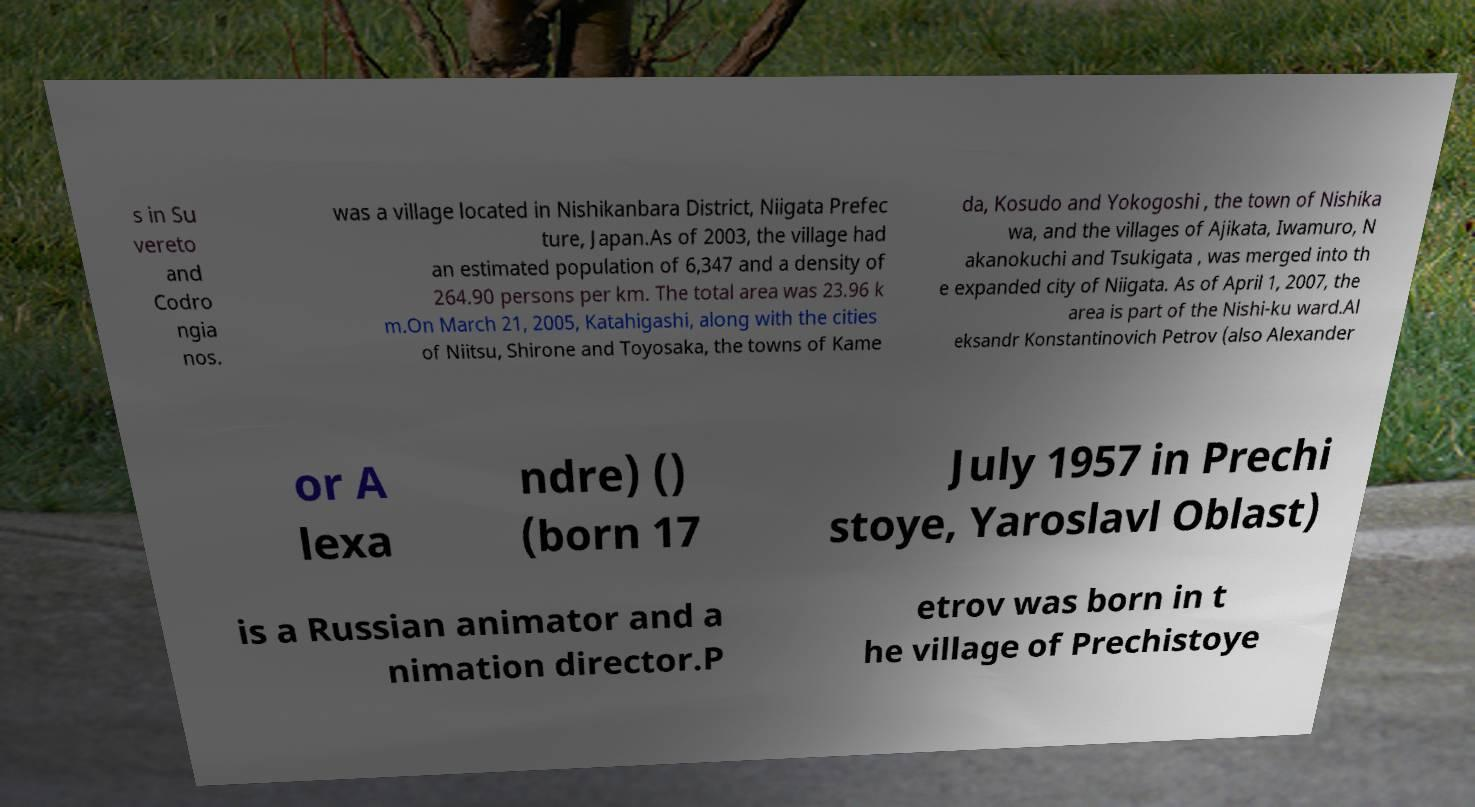What messages or text are displayed in this image? I need them in a readable, typed format. s in Su vereto and Codro ngia nos. was a village located in Nishikanbara District, Niigata Prefec ture, Japan.As of 2003, the village had an estimated population of 6,347 and a density of 264.90 persons per km. The total area was 23.96 k m.On March 21, 2005, Katahigashi, along with the cities of Niitsu, Shirone and Toyosaka, the towns of Kame da, Kosudo and Yokogoshi , the town of Nishika wa, and the villages of Ajikata, Iwamuro, N akanokuchi and Tsukigata , was merged into th e expanded city of Niigata. As of April 1, 2007, the area is part of the Nishi-ku ward.Al eksandr Konstantinovich Petrov (also Alexander or A lexa ndre) () (born 17 July 1957 in Prechi stoye, Yaroslavl Oblast) is a Russian animator and a nimation director.P etrov was born in t he village of Prechistoye 